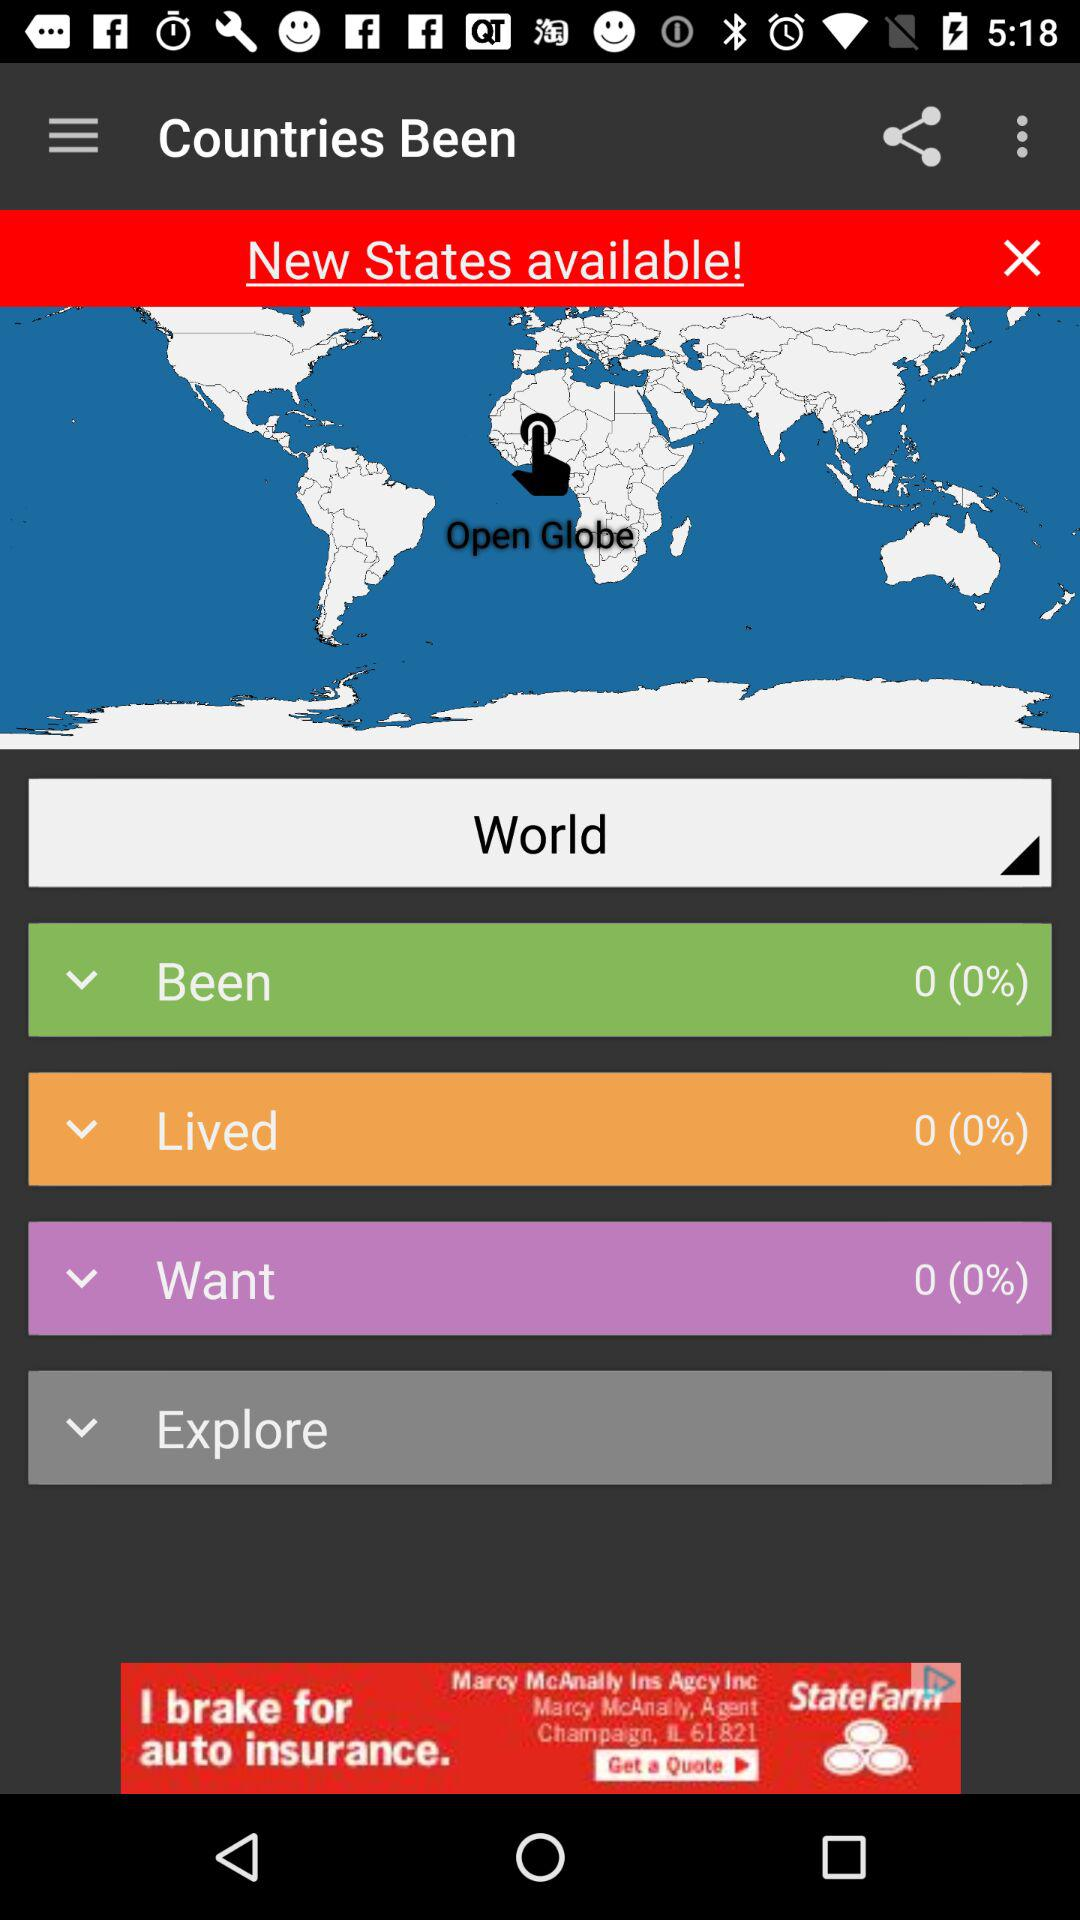What is the percentage of the "Been"? The percentage of the "Been" is 0. 